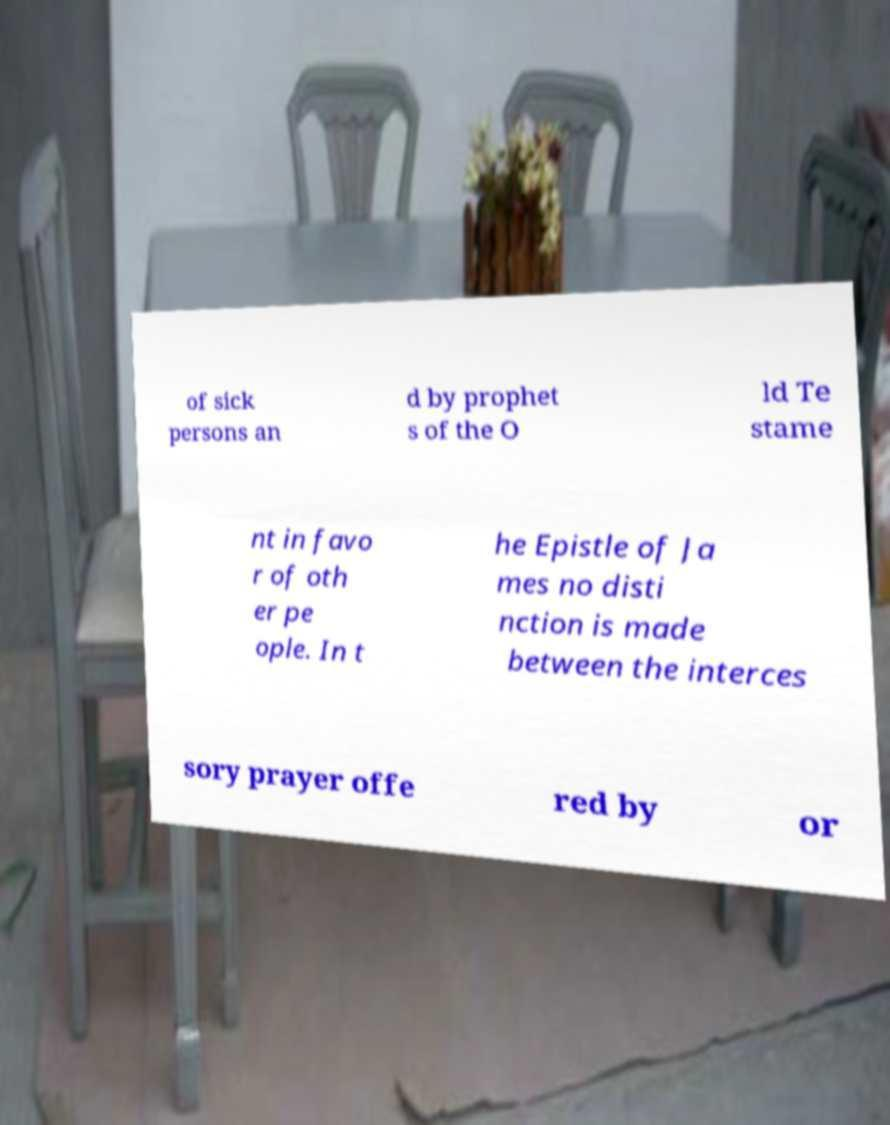What messages or text are displayed in this image? I need them in a readable, typed format. of sick persons an d by prophet s of the O ld Te stame nt in favo r of oth er pe ople. In t he Epistle of Ja mes no disti nction is made between the interces sory prayer offe red by or 